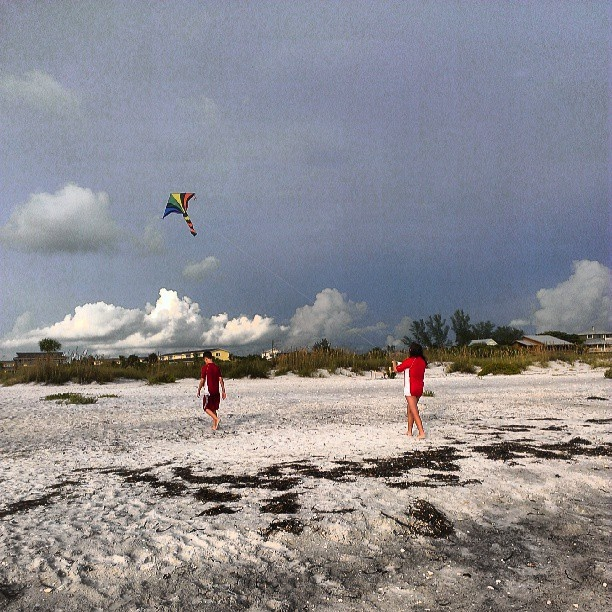Describe the objects in this image and their specific colors. I can see people in gray, brown, black, and maroon tones, people in gray, maroon, black, lightgray, and brown tones, and kite in gray, black, navy, and darkgray tones in this image. 